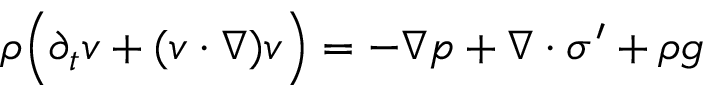Convert formula to latex. <formula><loc_0><loc_0><loc_500><loc_500>\begin{array} { r } { \rho \left ( \partial _ { t } v + ( v \cdot \nabla ) v \right ) = - \nabla p + \nabla \cdot \sigma ^ { \prime } + \rho g } \end{array}</formula> 